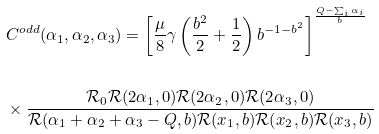<formula> <loc_0><loc_0><loc_500><loc_500>& C ^ { o d d } ( \alpha _ { 1 } , \alpha _ { 2 } , \alpha _ { 3 } ) = \left [ \frac { \mu } { 8 } \gamma \left ( \frac { b ^ { 2 } } { 2 } + \frac { 1 } { 2 } \right ) b ^ { - 1 - b ^ { 2 } } \right ] ^ { \frac { Q - \sum _ { i } \alpha _ { i } } { b } } \\ & \\ & \times \frac { \mathcal { R } _ { 0 } \mathcal { R } ( 2 \alpha _ { 1 } , 0 ) \mathcal { R } ( 2 \alpha _ { 2 } , 0 ) \mathcal { R } ( 2 \alpha _ { 3 } , 0 ) } { \mathcal { R } ( \alpha _ { 1 } + \alpha _ { 2 } + \alpha _ { 3 } - Q , b ) \mathcal { R } ( x _ { 1 } , b ) \mathcal { R } ( x _ { 2 } , b ) \mathcal { R } ( x _ { 3 } , b ) }</formula> 